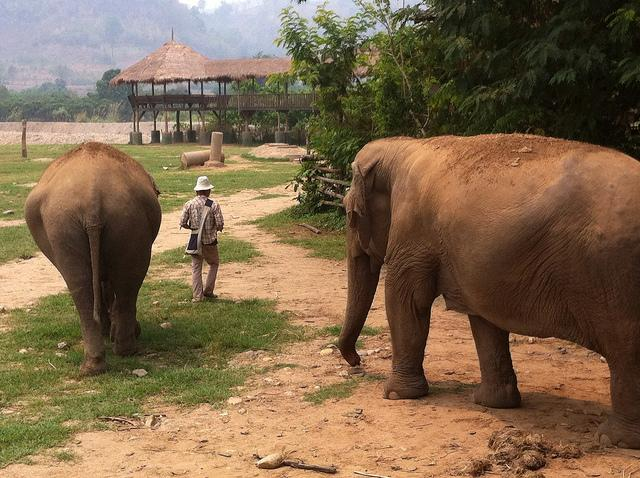What is between the elephants? Please explain your reasoning. man. There is a person. 